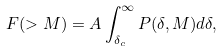Convert formula to latex. <formula><loc_0><loc_0><loc_500><loc_500>F ( > M ) = A \int _ { \delta _ { c } } ^ { \infty } P ( \delta , M ) d \delta ,</formula> 